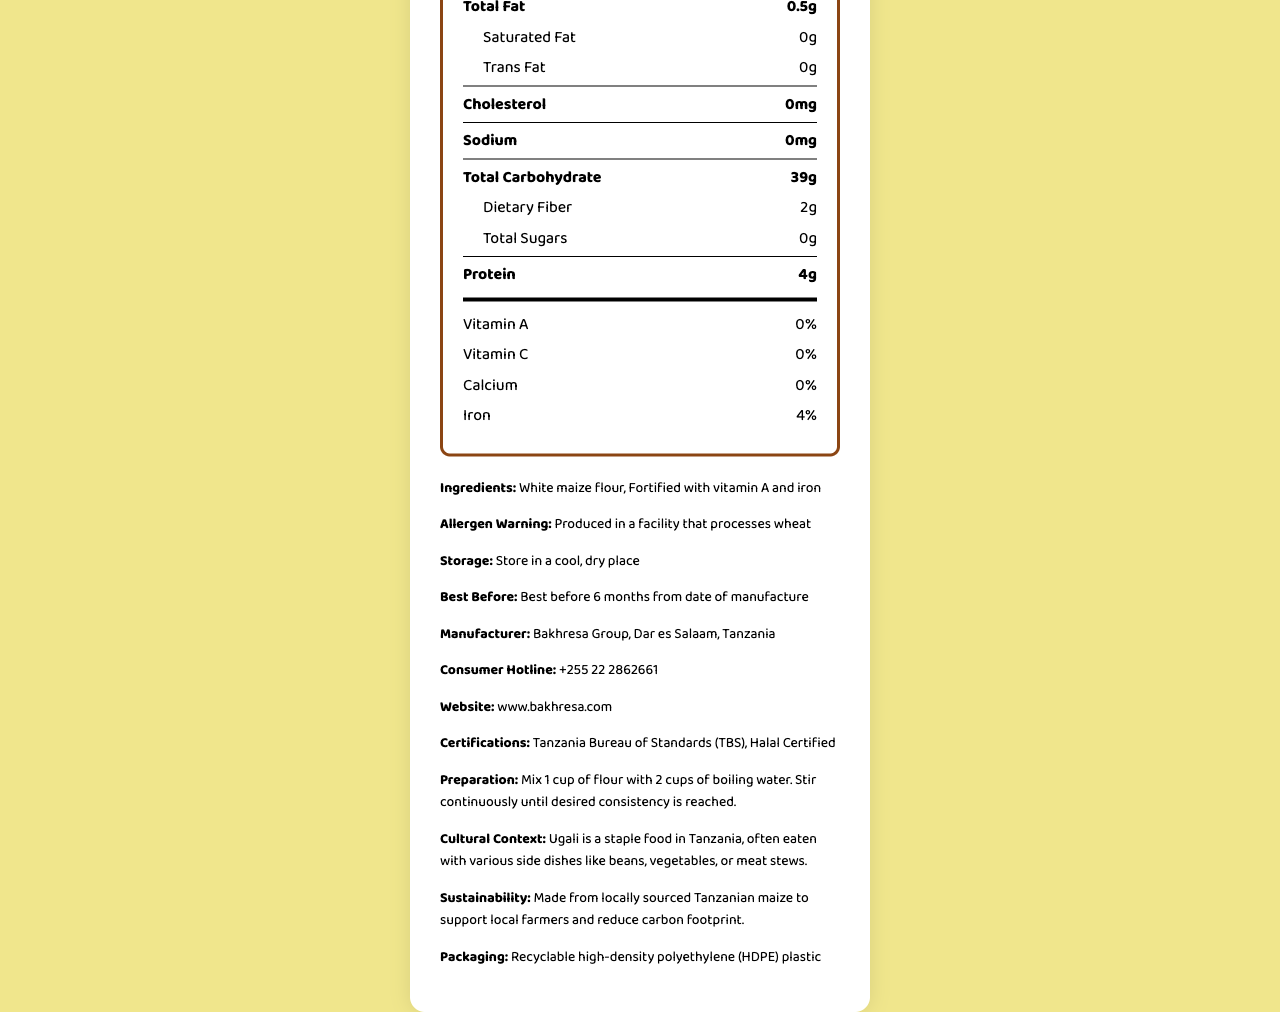what is the serving size of Sembe Ugali Flour? The serving size is listed as "Serving size 50g" in the nutrition label.
Answer: 50g how many servings are there per container? The document states "20 servings per container".
Answer: 20 what is the total carbohydrate content per serving? The nutrition label shows "Total Carbohydrate" as 39g per serving.
Answer: 39g which nutrient has the highest percentage daily value in the document? Iron has 4% daily value, while other listed nutrients (Vitamin A, Vitamin C, Calcium) have 0%.
Answer: Iron what is the contact number for the consumer hotline? The consumer hotline number is provided towards the end of the document as "+255 22 2862661".
Answer: +255 22 2862661 what is the calorie count per serving? The nutrition label states the calorie count per serving is 180.
Answer: 180 which ingredient is used in Sembe Ugali Flour? A. Wheat Flour B. White Maize Flour C. Rice Flour The ingredients listed are "White maize flour" and "Fortified with vitamin A and iron", making option B the correct answer.
Answer: B how should you store the Sembe Ugali Flour? The storage instructions advise to "Store in a cool, dry place".
Answer: Store in a cool, dry place what certifications does Sembe Ugali Flour have? A. ISO Certified B. Halal Certified C. TBS Certified D. Both B and C The document lists "Tanzania Bureau of Standards (TBS)" and "Halal Certified" under certifications.
Answer: D does the document state that Sembe Ugali Flour contains any sugars? The document shows "Total Sugars" as 0g per serving.
Answer: No does Sembe Ugali Flour contain any sodium? The sodium content per serving is shown as 0mg.
Answer: No summarize the entire document The document offers a comprehensive breakdown of Sembe Ugali Flour's nutritional value, manufacturing details, contact information, and other pertinent data for consumers.
Answer: The document provides detailed nutrition facts for Sembe Ugali Flour by Bakhresa Group. It lists the serving size, servings per container, calories, and specific nutrient quantities per serving, highlighting high carbohydrate and low protein content. Additional information includes ingredients, allergen warnings, storage instructions, expiration date, manufacturer information, contact details, certifications, preparation instructions, cultural context, sustainability info, and packaging material. what is the publication date of the document? The document does not provide a publication date, hence it can't be determined.
Answer: Not enough information 